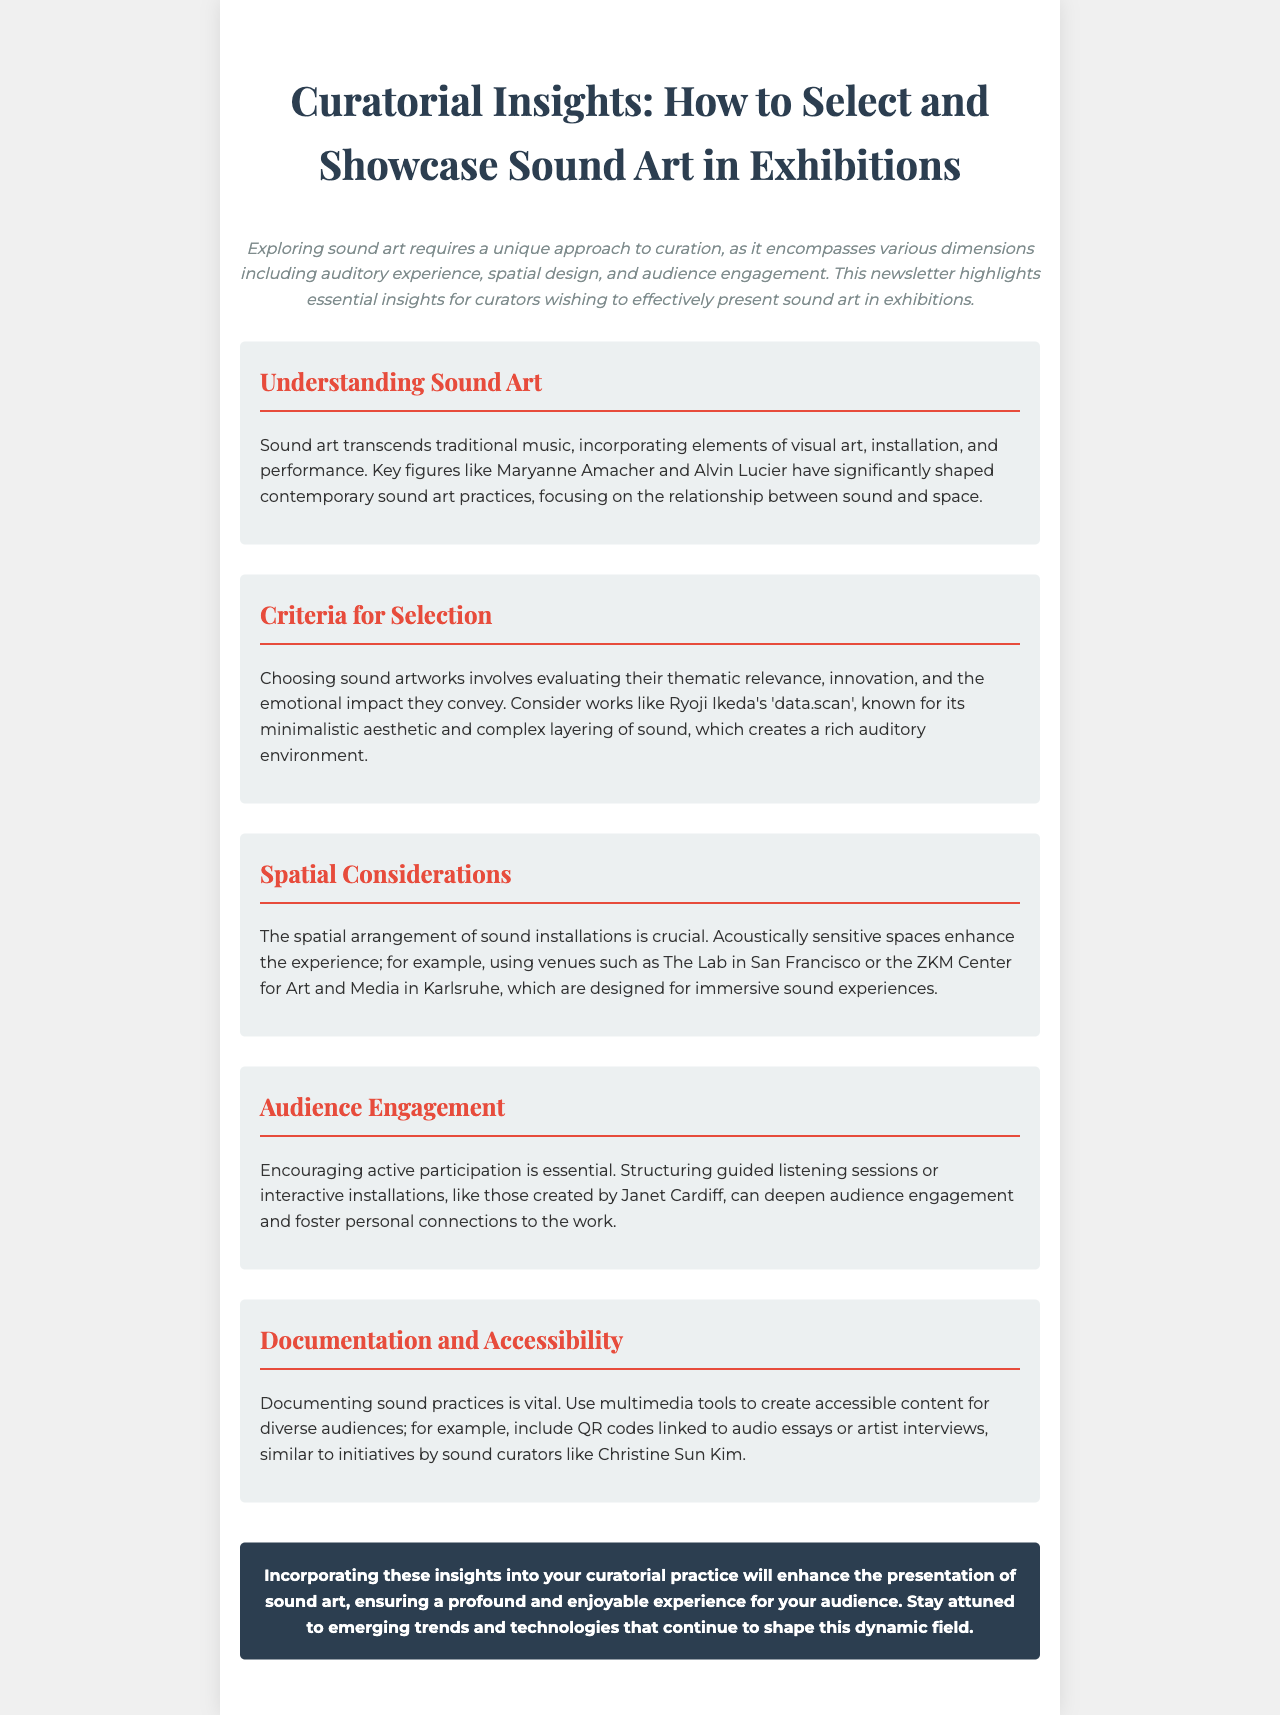What is the focus of sound art? The document states that sound art transcends traditional music and incorporates elements of visual art, installation, and performance.
Answer: Auditory experience Who are two key figures in contemporary sound art? The newsletter mentions Maryanne Amacher and Alvin Lucier as significant figures.
Answer: Maryanne Amacher, Alvin Lucier What is Ryoji Ikeda's notable work mentioned? The document references 'data.scan' as a significant piece known for its minimalistic aesthetic and complex layering of sound.
Answer: data.scan What type of spaces enhance sound installations? The document highlights that acoustically sensitive spaces enhance the experience of sound art.
Answer: Acoustically sensitive spaces What is a method to engage the audience according to the document? One suggested method for engaging audiences is structuring guided listening sessions.
Answer: Guided listening sessions Which two venues are cited as examples for immersive sound experiences? The document mentions The Lab in San Francisco and the ZKM Center for Art and Media in Karlsruhe as notable venues.
Answer: The Lab, ZKM Center What is vital for documenting sound practices? The newsletter asserts that using multimedia tools is vital for documenting sound practices effectively.
Answer: Multimedia tools Who is a sound curator mentioned for their initiatives? Christine Sun Kim is cited in relation to her initiatives for accessibility in sound practices.
Answer: Christine Sun Kim 